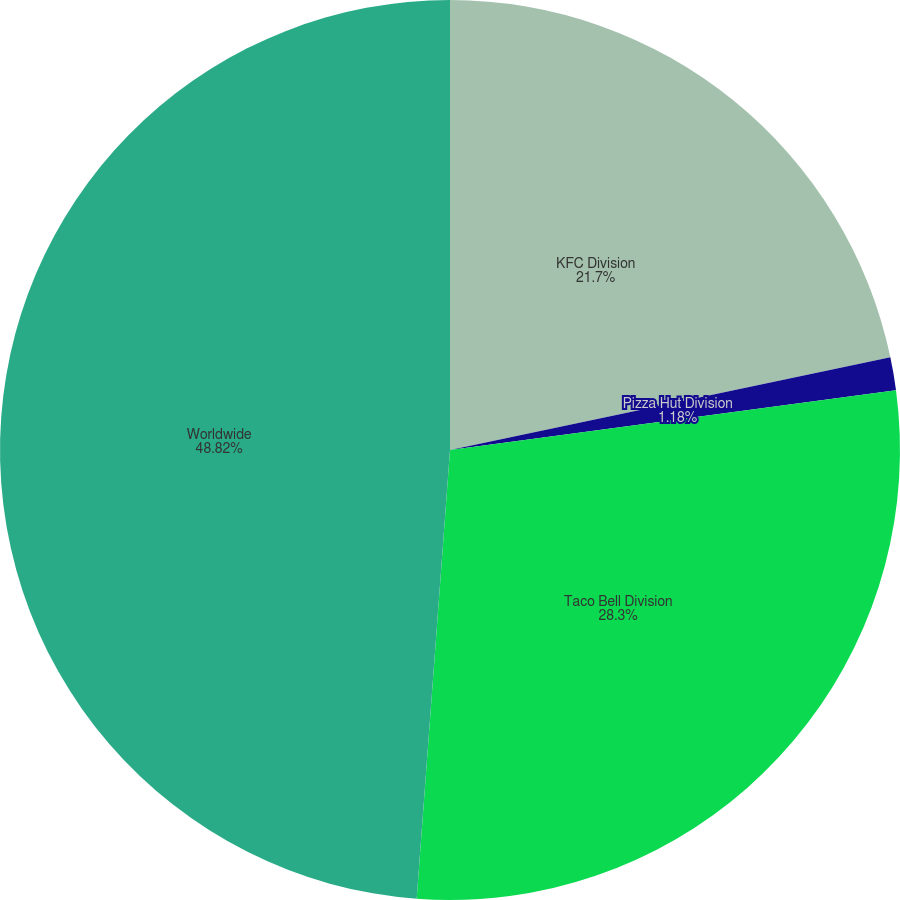Convert chart. <chart><loc_0><loc_0><loc_500><loc_500><pie_chart><fcel>KFC Division<fcel>Pizza Hut Division<fcel>Taco Bell Division<fcel>Worldwide<nl><fcel>21.7%<fcel>1.18%<fcel>28.3%<fcel>48.82%<nl></chart> 